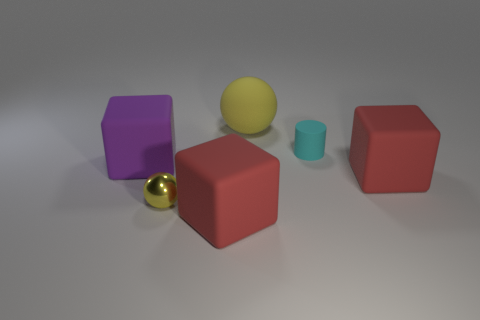There is a yellow ball that is left of the matte ball; is its size the same as the matte sphere?
Offer a terse response. No. What shape is the red object in front of the yellow metallic thing?
Provide a short and direct response. Cube. Are there more tiny objects than small blue matte cylinders?
Make the answer very short. Yes. There is a large cube that is left of the tiny yellow ball; does it have the same color as the tiny rubber cylinder?
Keep it short and to the point. No. What number of objects are either matte things in front of the matte sphere or large objects in front of the purple cube?
Provide a short and direct response. 4. How many cubes are to the right of the large purple block and behind the yellow shiny ball?
Offer a very short reply. 1. Is the material of the tiny cyan thing the same as the tiny sphere?
Your answer should be compact. No. There is a large red matte object behind the red thing that is on the left side of the yellow object to the right of the small ball; what is its shape?
Offer a terse response. Cube. There is a thing that is both behind the purple rubber object and in front of the rubber ball; what material is it made of?
Ensure brevity in your answer.  Rubber. What is the color of the small object that is in front of the red matte block that is to the right of the red object in front of the small yellow shiny thing?
Ensure brevity in your answer.  Yellow. 